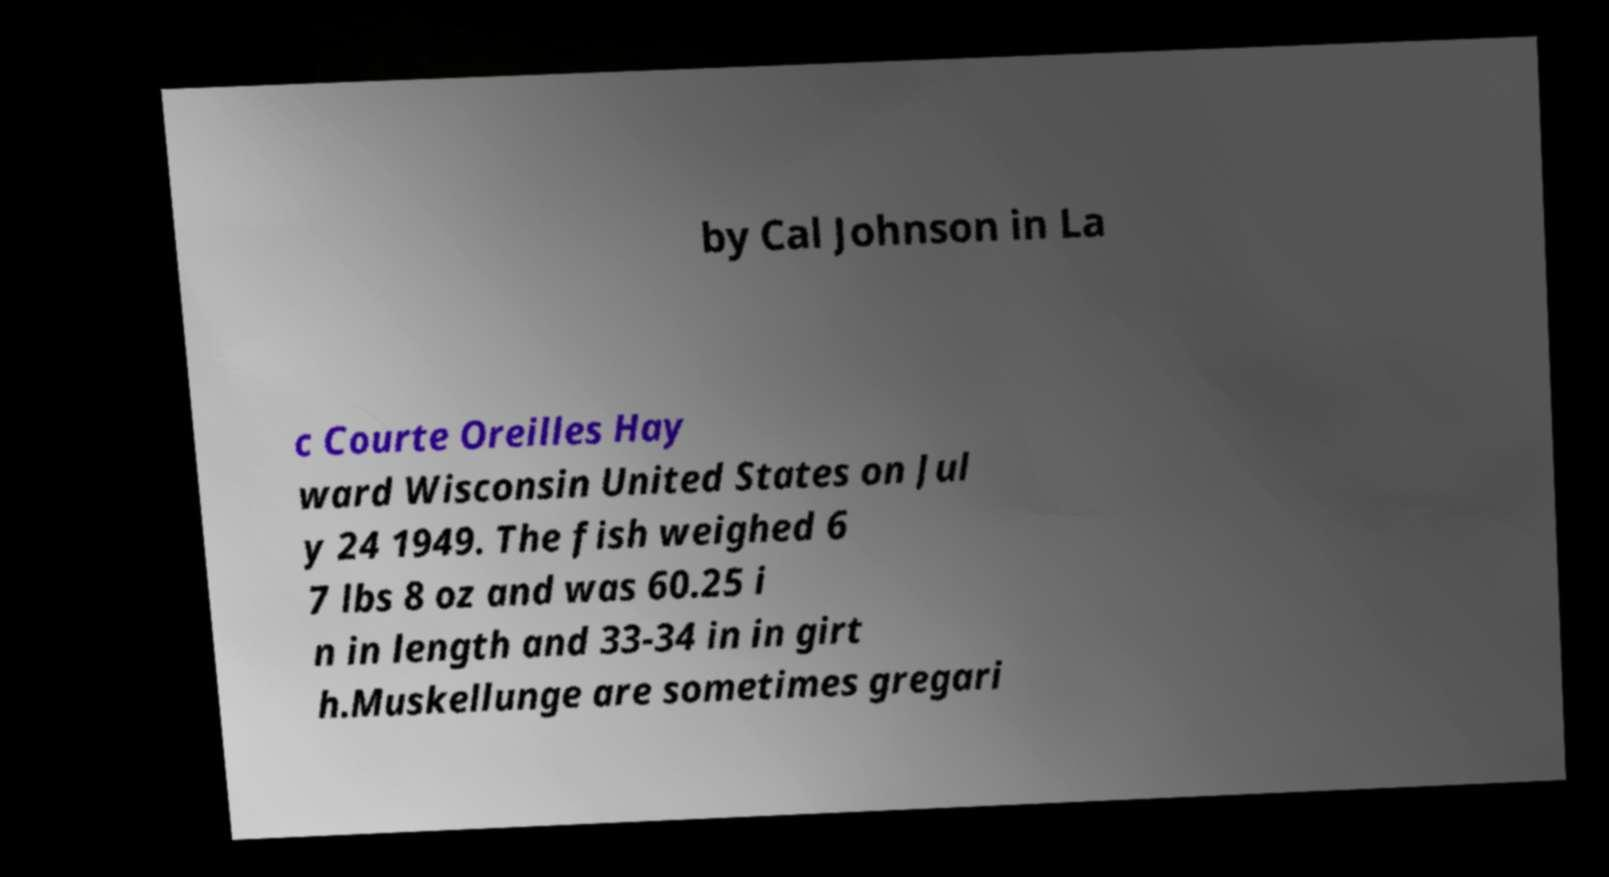What messages or text are displayed in this image? I need them in a readable, typed format. by Cal Johnson in La c Courte Oreilles Hay ward Wisconsin United States on Jul y 24 1949. The fish weighed 6 7 lbs 8 oz and was 60.25 i n in length and 33-34 in in girt h.Muskellunge are sometimes gregari 